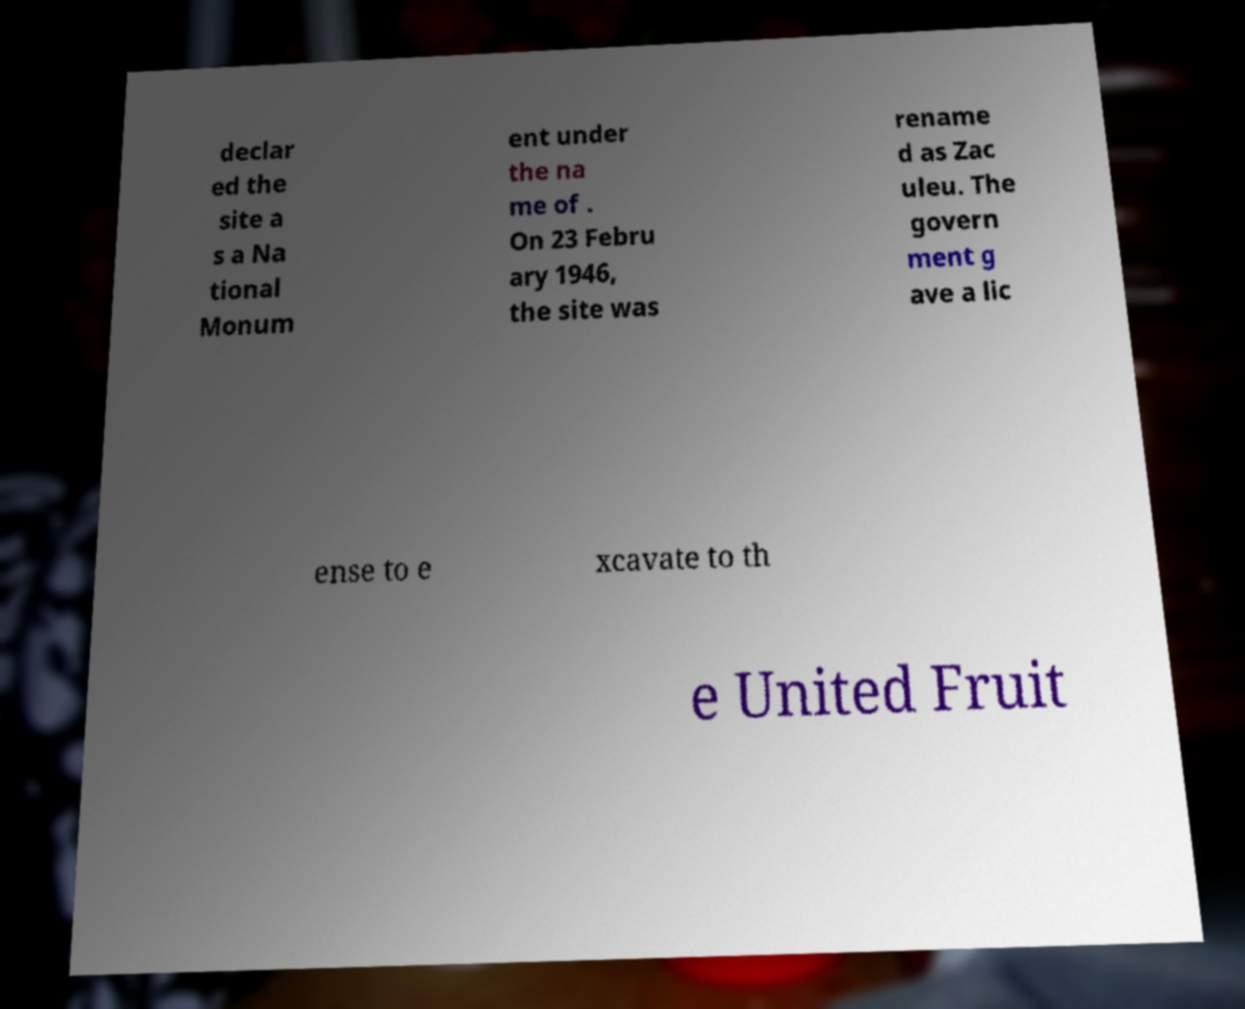What messages or text are displayed in this image? I need them in a readable, typed format. declar ed the site a s a Na tional Monum ent under the na me of . On 23 Febru ary 1946, the site was rename d as Zac uleu. The govern ment g ave a lic ense to e xcavate to th e United Fruit 